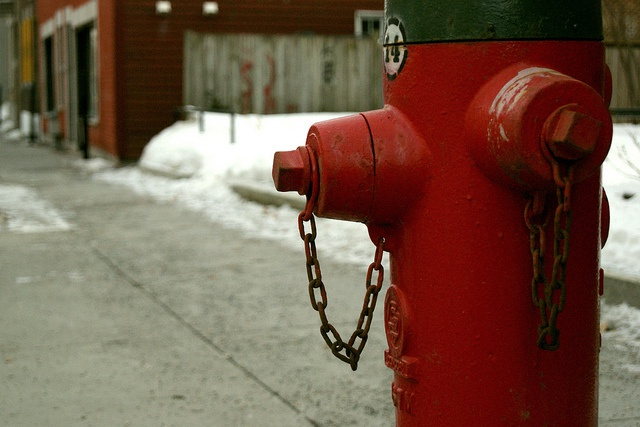Describe the objects in this image and their specific colors. I can see a fire hydrant in darkgreen, maroon, black, and brown tones in this image. 